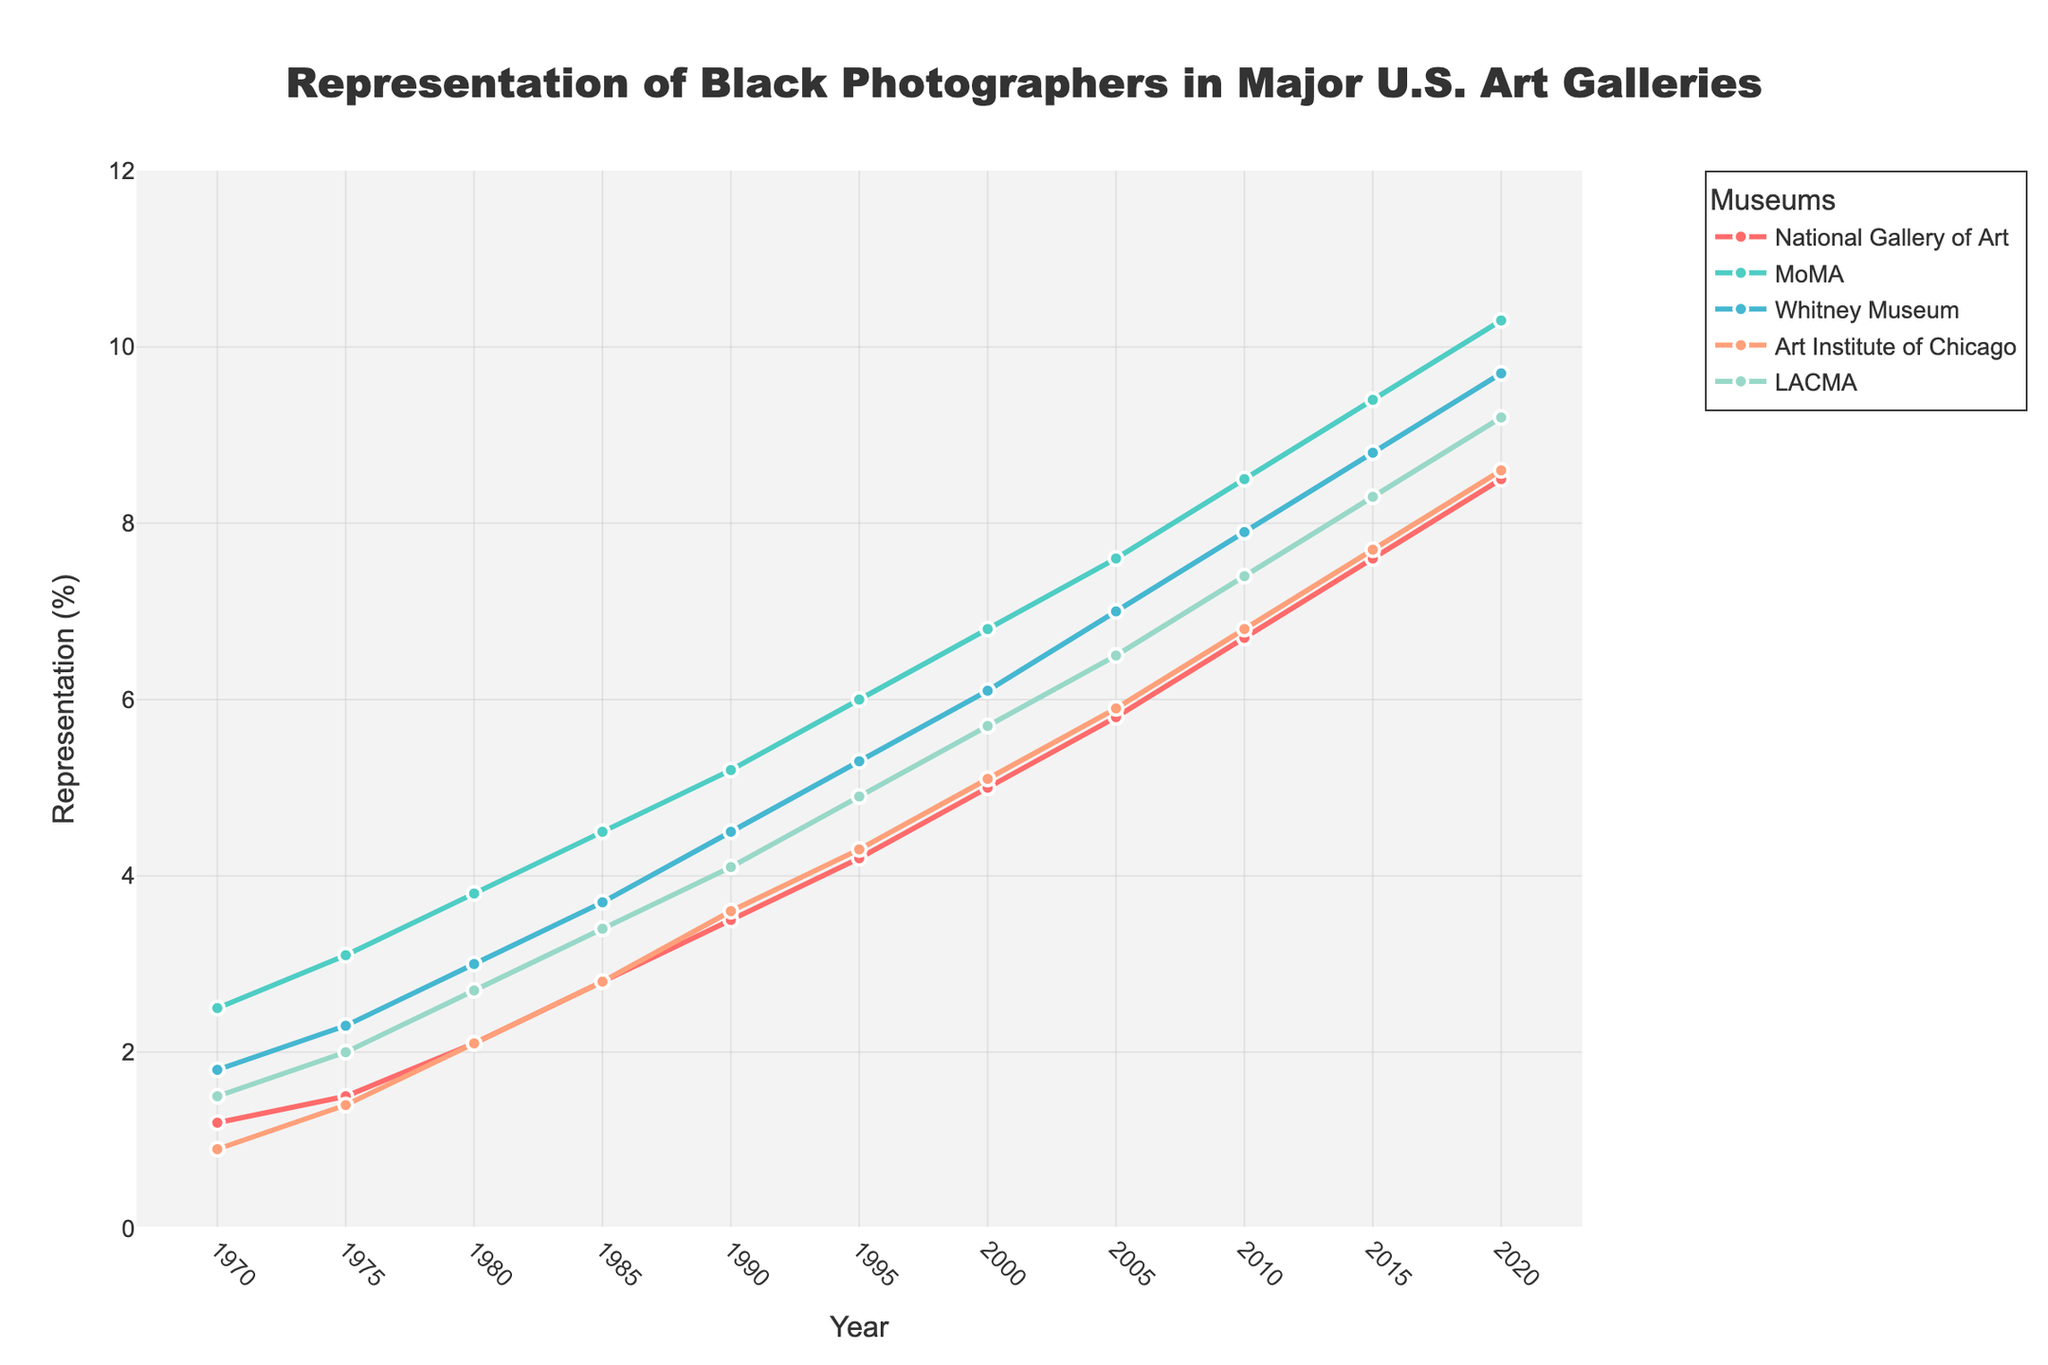How has the representation of Black photographers changed at the Whitney Museum from 1970 to 2020? To find this, look at the line for the Whitney Museum and compare the values in 1970 and 2020. In 1970, it was 1.8%, and in 2020, it was 9.7%.
Answer: Increased by 7.9% Which museum had the highest representation of Black photographers in 2020? Check the representation values for 2020 across all museums and pick the highest one. MoMA had a representation of 10.3%.
Answer: MoMA What is the average representation of Black photographers across all museums in 1990? Sum the values for all museums in 1990 and divide by the number of museums. (3.5 + 5.2 + 4.5 + 3.6 + 4.1) / 5 = 4.18
Answer: 4.18% Which museum showed the greatest increase in representation between any two consecutive periods? Look at the differences in percentages between all consecutive pairs for each museum. Compare all these differences to find the greatest increase. MoMA had the highest increase of 1.0% between 2015 and 2020.
Answer: MoMA between 2015 and 2020 How did the representation at the Art Institute of Chicago change between 2000 and 2005? Compare the values for the Art Institute of Chicago in 2000 (5.1%) and 2005 (5.9%).
Answer: Increased by 0.8% By how much did the representation at LACMA exceed that of the National Gallery of Art in 2010? Subtract the percentage for the National Gallery of Art in 2010 from that of LACMA in 2010. 7.4% - 6.7% = 0.7%
Answer: 0.7% Which two museums had the closest representation values in 1985? Look at the values for all museums in 1985 and find the pair with the smallest difference. The National Gallery of Art (2.8%) and the Art Institute of Chicago (2.8%) have the same value.
Answer: National Gallery of Art and Art Institute of Chicago What is the overall trend for the representation of Black photographers across all museums over the 50 years? Check the trend lines for each museum from 1970 to 2020. All lines show an upward trend over time, indicating an increase in representation.
Answer: Upward trend What was the total representation of Black photographers in all museums combined in 1970? Sum the percentages for all the museums in 1970. 1.2 + 2.5 + 1.8 + 0.9 + 1.5 = 7.9%
Answer: 7.9% Compare the change in representation between 1975 and 1980 for MoMA and the Whitney Museum. Which one had a higher increase? Calculate the change for MoMA (3.8% - 3.1% = 0.7%) and Whitney Museum (3.0% - 2.3% = 0.7%). Both had the same increase of 0.7%.
Answer: Both had the same increase 